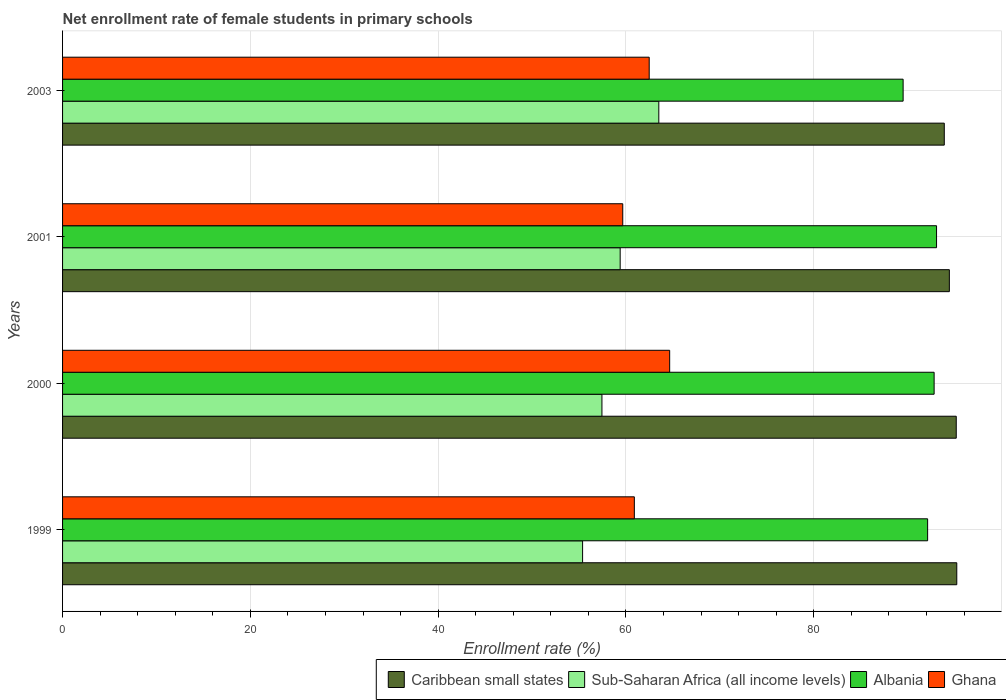Are the number of bars per tick equal to the number of legend labels?
Your answer should be compact. Yes. Are the number of bars on each tick of the Y-axis equal?
Your answer should be very brief. Yes. What is the label of the 3rd group of bars from the top?
Keep it short and to the point. 2000. What is the net enrollment rate of female students in primary schools in Albania in 2001?
Provide a succinct answer. 93.07. Across all years, what is the maximum net enrollment rate of female students in primary schools in Albania?
Your answer should be compact. 93.07. Across all years, what is the minimum net enrollment rate of female students in primary schools in Ghana?
Provide a short and direct response. 59.66. In which year was the net enrollment rate of female students in primary schools in Caribbean small states maximum?
Offer a very short reply. 1999. In which year was the net enrollment rate of female students in primary schools in Caribbean small states minimum?
Your answer should be very brief. 2003. What is the total net enrollment rate of female students in primary schools in Sub-Saharan Africa (all income levels) in the graph?
Offer a very short reply. 235.7. What is the difference between the net enrollment rate of female students in primary schools in Ghana in 1999 and that in 2000?
Offer a terse response. -3.76. What is the difference between the net enrollment rate of female students in primary schools in Caribbean small states in 2000 and the net enrollment rate of female students in primary schools in Ghana in 2001?
Make the answer very short. 35.52. What is the average net enrollment rate of female students in primary schools in Albania per year?
Give a very brief answer. 91.88. In the year 2000, what is the difference between the net enrollment rate of female students in primary schools in Sub-Saharan Africa (all income levels) and net enrollment rate of female students in primary schools in Caribbean small states?
Your response must be concise. -37.73. What is the ratio of the net enrollment rate of female students in primary schools in Sub-Saharan Africa (all income levels) in 1999 to that in 2003?
Your answer should be very brief. 0.87. Is the net enrollment rate of female students in primary schools in Ghana in 1999 less than that in 2000?
Make the answer very short. Yes. What is the difference between the highest and the second highest net enrollment rate of female students in primary schools in Sub-Saharan Africa (all income levels)?
Ensure brevity in your answer.  4.11. What is the difference between the highest and the lowest net enrollment rate of female students in primary schools in Ghana?
Your response must be concise. 5. What does the 1st bar from the top in 2000 represents?
Offer a very short reply. Ghana. What does the 2nd bar from the bottom in 2003 represents?
Your answer should be compact. Sub-Saharan Africa (all income levels). Is it the case that in every year, the sum of the net enrollment rate of female students in primary schools in Ghana and net enrollment rate of female students in primary schools in Albania is greater than the net enrollment rate of female students in primary schools in Sub-Saharan Africa (all income levels)?
Make the answer very short. Yes. How many years are there in the graph?
Your answer should be very brief. 4. What is the difference between two consecutive major ticks on the X-axis?
Provide a short and direct response. 20. Are the values on the major ticks of X-axis written in scientific E-notation?
Your response must be concise. No. Does the graph contain any zero values?
Offer a very short reply. No. Where does the legend appear in the graph?
Your answer should be very brief. Bottom right. How many legend labels are there?
Your response must be concise. 4. What is the title of the graph?
Provide a short and direct response. Net enrollment rate of female students in primary schools. Does "Denmark" appear as one of the legend labels in the graph?
Your answer should be compact. No. What is the label or title of the X-axis?
Offer a terse response. Enrollment rate (%). What is the label or title of the Y-axis?
Give a very brief answer. Years. What is the Enrollment rate (%) of Caribbean small states in 1999?
Your response must be concise. 95.23. What is the Enrollment rate (%) in Sub-Saharan Africa (all income levels) in 1999?
Your response must be concise. 55.38. What is the Enrollment rate (%) of Albania in 1999?
Make the answer very short. 92.12. What is the Enrollment rate (%) of Ghana in 1999?
Make the answer very short. 60.89. What is the Enrollment rate (%) in Caribbean small states in 2000?
Give a very brief answer. 95.17. What is the Enrollment rate (%) of Sub-Saharan Africa (all income levels) in 2000?
Provide a short and direct response. 57.44. What is the Enrollment rate (%) in Albania in 2000?
Your answer should be compact. 92.82. What is the Enrollment rate (%) of Ghana in 2000?
Offer a terse response. 64.65. What is the Enrollment rate (%) of Caribbean small states in 2001?
Keep it short and to the point. 94.44. What is the Enrollment rate (%) in Sub-Saharan Africa (all income levels) in 2001?
Provide a succinct answer. 59.38. What is the Enrollment rate (%) of Albania in 2001?
Ensure brevity in your answer.  93.07. What is the Enrollment rate (%) in Ghana in 2001?
Make the answer very short. 59.66. What is the Enrollment rate (%) in Caribbean small states in 2003?
Your answer should be compact. 93.9. What is the Enrollment rate (%) in Sub-Saharan Africa (all income levels) in 2003?
Offer a terse response. 63.5. What is the Enrollment rate (%) of Albania in 2003?
Your answer should be very brief. 89.51. What is the Enrollment rate (%) of Ghana in 2003?
Your response must be concise. 62.47. Across all years, what is the maximum Enrollment rate (%) in Caribbean small states?
Ensure brevity in your answer.  95.23. Across all years, what is the maximum Enrollment rate (%) in Sub-Saharan Africa (all income levels)?
Provide a short and direct response. 63.5. Across all years, what is the maximum Enrollment rate (%) of Albania?
Keep it short and to the point. 93.07. Across all years, what is the maximum Enrollment rate (%) of Ghana?
Offer a very short reply. 64.65. Across all years, what is the minimum Enrollment rate (%) of Caribbean small states?
Offer a very short reply. 93.9. Across all years, what is the minimum Enrollment rate (%) of Sub-Saharan Africa (all income levels)?
Provide a succinct answer. 55.38. Across all years, what is the minimum Enrollment rate (%) of Albania?
Keep it short and to the point. 89.51. Across all years, what is the minimum Enrollment rate (%) in Ghana?
Your answer should be compact. 59.66. What is the total Enrollment rate (%) in Caribbean small states in the graph?
Make the answer very short. 378.74. What is the total Enrollment rate (%) in Sub-Saharan Africa (all income levels) in the graph?
Keep it short and to the point. 235.7. What is the total Enrollment rate (%) in Albania in the graph?
Offer a terse response. 367.53. What is the total Enrollment rate (%) in Ghana in the graph?
Make the answer very short. 247.67. What is the difference between the Enrollment rate (%) of Caribbean small states in 1999 and that in 2000?
Offer a very short reply. 0.06. What is the difference between the Enrollment rate (%) in Sub-Saharan Africa (all income levels) in 1999 and that in 2000?
Provide a short and direct response. -2.06. What is the difference between the Enrollment rate (%) in Albania in 1999 and that in 2000?
Ensure brevity in your answer.  -0.69. What is the difference between the Enrollment rate (%) of Ghana in 1999 and that in 2000?
Your answer should be very brief. -3.76. What is the difference between the Enrollment rate (%) of Caribbean small states in 1999 and that in 2001?
Make the answer very short. 0.79. What is the difference between the Enrollment rate (%) of Sub-Saharan Africa (all income levels) in 1999 and that in 2001?
Your answer should be compact. -4. What is the difference between the Enrollment rate (%) in Albania in 1999 and that in 2001?
Offer a very short reply. -0.95. What is the difference between the Enrollment rate (%) in Ghana in 1999 and that in 2001?
Give a very brief answer. 1.23. What is the difference between the Enrollment rate (%) in Caribbean small states in 1999 and that in 2003?
Keep it short and to the point. 1.33. What is the difference between the Enrollment rate (%) of Sub-Saharan Africa (all income levels) in 1999 and that in 2003?
Your response must be concise. -8.12. What is the difference between the Enrollment rate (%) of Albania in 1999 and that in 2003?
Offer a very short reply. 2.61. What is the difference between the Enrollment rate (%) in Ghana in 1999 and that in 2003?
Your answer should be very brief. -1.58. What is the difference between the Enrollment rate (%) in Caribbean small states in 2000 and that in 2001?
Your answer should be very brief. 0.73. What is the difference between the Enrollment rate (%) of Sub-Saharan Africa (all income levels) in 2000 and that in 2001?
Give a very brief answer. -1.94. What is the difference between the Enrollment rate (%) in Albania in 2000 and that in 2001?
Your response must be concise. -0.26. What is the difference between the Enrollment rate (%) in Ghana in 2000 and that in 2001?
Offer a terse response. 5. What is the difference between the Enrollment rate (%) of Caribbean small states in 2000 and that in 2003?
Your answer should be very brief. 1.27. What is the difference between the Enrollment rate (%) of Sub-Saharan Africa (all income levels) in 2000 and that in 2003?
Your answer should be very brief. -6.06. What is the difference between the Enrollment rate (%) of Albania in 2000 and that in 2003?
Your response must be concise. 3.3. What is the difference between the Enrollment rate (%) in Ghana in 2000 and that in 2003?
Give a very brief answer. 2.18. What is the difference between the Enrollment rate (%) in Caribbean small states in 2001 and that in 2003?
Your answer should be very brief. 0.54. What is the difference between the Enrollment rate (%) in Sub-Saharan Africa (all income levels) in 2001 and that in 2003?
Keep it short and to the point. -4.11. What is the difference between the Enrollment rate (%) in Albania in 2001 and that in 2003?
Provide a succinct answer. 3.56. What is the difference between the Enrollment rate (%) of Ghana in 2001 and that in 2003?
Provide a short and direct response. -2.82. What is the difference between the Enrollment rate (%) of Caribbean small states in 1999 and the Enrollment rate (%) of Sub-Saharan Africa (all income levels) in 2000?
Give a very brief answer. 37.79. What is the difference between the Enrollment rate (%) in Caribbean small states in 1999 and the Enrollment rate (%) in Albania in 2000?
Provide a succinct answer. 2.41. What is the difference between the Enrollment rate (%) in Caribbean small states in 1999 and the Enrollment rate (%) in Ghana in 2000?
Ensure brevity in your answer.  30.58. What is the difference between the Enrollment rate (%) of Sub-Saharan Africa (all income levels) in 1999 and the Enrollment rate (%) of Albania in 2000?
Your answer should be compact. -37.44. What is the difference between the Enrollment rate (%) in Sub-Saharan Africa (all income levels) in 1999 and the Enrollment rate (%) in Ghana in 2000?
Your answer should be compact. -9.27. What is the difference between the Enrollment rate (%) of Albania in 1999 and the Enrollment rate (%) of Ghana in 2000?
Your answer should be very brief. 27.47. What is the difference between the Enrollment rate (%) of Caribbean small states in 1999 and the Enrollment rate (%) of Sub-Saharan Africa (all income levels) in 2001?
Offer a very short reply. 35.85. What is the difference between the Enrollment rate (%) of Caribbean small states in 1999 and the Enrollment rate (%) of Albania in 2001?
Provide a succinct answer. 2.16. What is the difference between the Enrollment rate (%) of Caribbean small states in 1999 and the Enrollment rate (%) of Ghana in 2001?
Give a very brief answer. 35.57. What is the difference between the Enrollment rate (%) in Sub-Saharan Africa (all income levels) in 1999 and the Enrollment rate (%) in Albania in 2001?
Give a very brief answer. -37.69. What is the difference between the Enrollment rate (%) in Sub-Saharan Africa (all income levels) in 1999 and the Enrollment rate (%) in Ghana in 2001?
Offer a very short reply. -4.28. What is the difference between the Enrollment rate (%) of Albania in 1999 and the Enrollment rate (%) of Ghana in 2001?
Provide a short and direct response. 32.47. What is the difference between the Enrollment rate (%) in Caribbean small states in 1999 and the Enrollment rate (%) in Sub-Saharan Africa (all income levels) in 2003?
Give a very brief answer. 31.73. What is the difference between the Enrollment rate (%) in Caribbean small states in 1999 and the Enrollment rate (%) in Albania in 2003?
Your answer should be compact. 5.71. What is the difference between the Enrollment rate (%) in Caribbean small states in 1999 and the Enrollment rate (%) in Ghana in 2003?
Offer a very short reply. 32.75. What is the difference between the Enrollment rate (%) of Sub-Saharan Africa (all income levels) in 1999 and the Enrollment rate (%) of Albania in 2003?
Provide a succinct answer. -34.13. What is the difference between the Enrollment rate (%) in Sub-Saharan Africa (all income levels) in 1999 and the Enrollment rate (%) in Ghana in 2003?
Offer a terse response. -7.09. What is the difference between the Enrollment rate (%) of Albania in 1999 and the Enrollment rate (%) of Ghana in 2003?
Your response must be concise. 29.65. What is the difference between the Enrollment rate (%) of Caribbean small states in 2000 and the Enrollment rate (%) of Sub-Saharan Africa (all income levels) in 2001?
Provide a succinct answer. 35.79. What is the difference between the Enrollment rate (%) in Caribbean small states in 2000 and the Enrollment rate (%) in Albania in 2001?
Offer a very short reply. 2.1. What is the difference between the Enrollment rate (%) in Caribbean small states in 2000 and the Enrollment rate (%) in Ghana in 2001?
Provide a short and direct response. 35.52. What is the difference between the Enrollment rate (%) in Sub-Saharan Africa (all income levels) in 2000 and the Enrollment rate (%) in Albania in 2001?
Your response must be concise. -35.63. What is the difference between the Enrollment rate (%) in Sub-Saharan Africa (all income levels) in 2000 and the Enrollment rate (%) in Ghana in 2001?
Provide a short and direct response. -2.22. What is the difference between the Enrollment rate (%) of Albania in 2000 and the Enrollment rate (%) of Ghana in 2001?
Offer a very short reply. 33.16. What is the difference between the Enrollment rate (%) of Caribbean small states in 2000 and the Enrollment rate (%) of Sub-Saharan Africa (all income levels) in 2003?
Give a very brief answer. 31.68. What is the difference between the Enrollment rate (%) of Caribbean small states in 2000 and the Enrollment rate (%) of Albania in 2003?
Give a very brief answer. 5.66. What is the difference between the Enrollment rate (%) of Caribbean small states in 2000 and the Enrollment rate (%) of Ghana in 2003?
Provide a succinct answer. 32.7. What is the difference between the Enrollment rate (%) in Sub-Saharan Africa (all income levels) in 2000 and the Enrollment rate (%) in Albania in 2003?
Offer a very short reply. -32.08. What is the difference between the Enrollment rate (%) in Sub-Saharan Africa (all income levels) in 2000 and the Enrollment rate (%) in Ghana in 2003?
Make the answer very short. -5.03. What is the difference between the Enrollment rate (%) of Albania in 2000 and the Enrollment rate (%) of Ghana in 2003?
Provide a succinct answer. 30.34. What is the difference between the Enrollment rate (%) of Caribbean small states in 2001 and the Enrollment rate (%) of Sub-Saharan Africa (all income levels) in 2003?
Offer a terse response. 30.94. What is the difference between the Enrollment rate (%) in Caribbean small states in 2001 and the Enrollment rate (%) in Albania in 2003?
Your answer should be compact. 4.92. What is the difference between the Enrollment rate (%) of Caribbean small states in 2001 and the Enrollment rate (%) of Ghana in 2003?
Offer a terse response. 31.96. What is the difference between the Enrollment rate (%) of Sub-Saharan Africa (all income levels) in 2001 and the Enrollment rate (%) of Albania in 2003?
Provide a short and direct response. -30.13. What is the difference between the Enrollment rate (%) in Sub-Saharan Africa (all income levels) in 2001 and the Enrollment rate (%) in Ghana in 2003?
Your answer should be compact. -3.09. What is the difference between the Enrollment rate (%) of Albania in 2001 and the Enrollment rate (%) of Ghana in 2003?
Your answer should be compact. 30.6. What is the average Enrollment rate (%) in Caribbean small states per year?
Your answer should be very brief. 94.68. What is the average Enrollment rate (%) in Sub-Saharan Africa (all income levels) per year?
Your response must be concise. 58.92. What is the average Enrollment rate (%) of Albania per year?
Your response must be concise. 91.88. What is the average Enrollment rate (%) in Ghana per year?
Offer a very short reply. 61.92. In the year 1999, what is the difference between the Enrollment rate (%) of Caribbean small states and Enrollment rate (%) of Sub-Saharan Africa (all income levels)?
Your response must be concise. 39.85. In the year 1999, what is the difference between the Enrollment rate (%) of Caribbean small states and Enrollment rate (%) of Albania?
Provide a short and direct response. 3.11. In the year 1999, what is the difference between the Enrollment rate (%) of Caribbean small states and Enrollment rate (%) of Ghana?
Provide a succinct answer. 34.34. In the year 1999, what is the difference between the Enrollment rate (%) of Sub-Saharan Africa (all income levels) and Enrollment rate (%) of Albania?
Provide a short and direct response. -36.74. In the year 1999, what is the difference between the Enrollment rate (%) in Sub-Saharan Africa (all income levels) and Enrollment rate (%) in Ghana?
Your answer should be compact. -5.51. In the year 1999, what is the difference between the Enrollment rate (%) of Albania and Enrollment rate (%) of Ghana?
Offer a terse response. 31.23. In the year 2000, what is the difference between the Enrollment rate (%) in Caribbean small states and Enrollment rate (%) in Sub-Saharan Africa (all income levels)?
Provide a short and direct response. 37.73. In the year 2000, what is the difference between the Enrollment rate (%) of Caribbean small states and Enrollment rate (%) of Albania?
Offer a terse response. 2.36. In the year 2000, what is the difference between the Enrollment rate (%) of Caribbean small states and Enrollment rate (%) of Ghana?
Offer a terse response. 30.52. In the year 2000, what is the difference between the Enrollment rate (%) of Sub-Saharan Africa (all income levels) and Enrollment rate (%) of Albania?
Your answer should be compact. -35.38. In the year 2000, what is the difference between the Enrollment rate (%) in Sub-Saharan Africa (all income levels) and Enrollment rate (%) in Ghana?
Provide a succinct answer. -7.21. In the year 2000, what is the difference between the Enrollment rate (%) of Albania and Enrollment rate (%) of Ghana?
Provide a succinct answer. 28.16. In the year 2001, what is the difference between the Enrollment rate (%) of Caribbean small states and Enrollment rate (%) of Sub-Saharan Africa (all income levels)?
Keep it short and to the point. 35.06. In the year 2001, what is the difference between the Enrollment rate (%) of Caribbean small states and Enrollment rate (%) of Albania?
Provide a succinct answer. 1.36. In the year 2001, what is the difference between the Enrollment rate (%) in Caribbean small states and Enrollment rate (%) in Ghana?
Provide a succinct answer. 34.78. In the year 2001, what is the difference between the Enrollment rate (%) of Sub-Saharan Africa (all income levels) and Enrollment rate (%) of Albania?
Your response must be concise. -33.69. In the year 2001, what is the difference between the Enrollment rate (%) of Sub-Saharan Africa (all income levels) and Enrollment rate (%) of Ghana?
Provide a succinct answer. -0.27. In the year 2001, what is the difference between the Enrollment rate (%) in Albania and Enrollment rate (%) in Ghana?
Your answer should be very brief. 33.42. In the year 2003, what is the difference between the Enrollment rate (%) of Caribbean small states and Enrollment rate (%) of Sub-Saharan Africa (all income levels)?
Offer a terse response. 30.4. In the year 2003, what is the difference between the Enrollment rate (%) of Caribbean small states and Enrollment rate (%) of Albania?
Your response must be concise. 4.38. In the year 2003, what is the difference between the Enrollment rate (%) in Caribbean small states and Enrollment rate (%) in Ghana?
Your answer should be very brief. 31.42. In the year 2003, what is the difference between the Enrollment rate (%) in Sub-Saharan Africa (all income levels) and Enrollment rate (%) in Albania?
Your answer should be very brief. -26.02. In the year 2003, what is the difference between the Enrollment rate (%) in Albania and Enrollment rate (%) in Ghana?
Your response must be concise. 27.04. What is the ratio of the Enrollment rate (%) in Sub-Saharan Africa (all income levels) in 1999 to that in 2000?
Ensure brevity in your answer.  0.96. What is the ratio of the Enrollment rate (%) of Ghana in 1999 to that in 2000?
Offer a terse response. 0.94. What is the ratio of the Enrollment rate (%) of Caribbean small states in 1999 to that in 2001?
Provide a short and direct response. 1.01. What is the ratio of the Enrollment rate (%) in Sub-Saharan Africa (all income levels) in 1999 to that in 2001?
Offer a very short reply. 0.93. What is the ratio of the Enrollment rate (%) in Ghana in 1999 to that in 2001?
Your answer should be compact. 1.02. What is the ratio of the Enrollment rate (%) of Caribbean small states in 1999 to that in 2003?
Provide a short and direct response. 1.01. What is the ratio of the Enrollment rate (%) in Sub-Saharan Africa (all income levels) in 1999 to that in 2003?
Your response must be concise. 0.87. What is the ratio of the Enrollment rate (%) in Albania in 1999 to that in 2003?
Make the answer very short. 1.03. What is the ratio of the Enrollment rate (%) in Ghana in 1999 to that in 2003?
Your answer should be compact. 0.97. What is the ratio of the Enrollment rate (%) of Caribbean small states in 2000 to that in 2001?
Offer a very short reply. 1.01. What is the ratio of the Enrollment rate (%) in Sub-Saharan Africa (all income levels) in 2000 to that in 2001?
Provide a short and direct response. 0.97. What is the ratio of the Enrollment rate (%) of Ghana in 2000 to that in 2001?
Offer a very short reply. 1.08. What is the ratio of the Enrollment rate (%) in Caribbean small states in 2000 to that in 2003?
Your answer should be compact. 1.01. What is the ratio of the Enrollment rate (%) of Sub-Saharan Africa (all income levels) in 2000 to that in 2003?
Give a very brief answer. 0.9. What is the ratio of the Enrollment rate (%) in Albania in 2000 to that in 2003?
Provide a short and direct response. 1.04. What is the ratio of the Enrollment rate (%) in Ghana in 2000 to that in 2003?
Make the answer very short. 1.03. What is the ratio of the Enrollment rate (%) of Sub-Saharan Africa (all income levels) in 2001 to that in 2003?
Give a very brief answer. 0.94. What is the ratio of the Enrollment rate (%) in Albania in 2001 to that in 2003?
Provide a short and direct response. 1.04. What is the ratio of the Enrollment rate (%) in Ghana in 2001 to that in 2003?
Ensure brevity in your answer.  0.95. What is the difference between the highest and the second highest Enrollment rate (%) in Caribbean small states?
Offer a very short reply. 0.06. What is the difference between the highest and the second highest Enrollment rate (%) in Sub-Saharan Africa (all income levels)?
Your response must be concise. 4.11. What is the difference between the highest and the second highest Enrollment rate (%) of Albania?
Make the answer very short. 0.26. What is the difference between the highest and the second highest Enrollment rate (%) of Ghana?
Give a very brief answer. 2.18. What is the difference between the highest and the lowest Enrollment rate (%) in Caribbean small states?
Offer a very short reply. 1.33. What is the difference between the highest and the lowest Enrollment rate (%) in Sub-Saharan Africa (all income levels)?
Make the answer very short. 8.12. What is the difference between the highest and the lowest Enrollment rate (%) in Albania?
Your answer should be very brief. 3.56. What is the difference between the highest and the lowest Enrollment rate (%) in Ghana?
Provide a short and direct response. 5. 